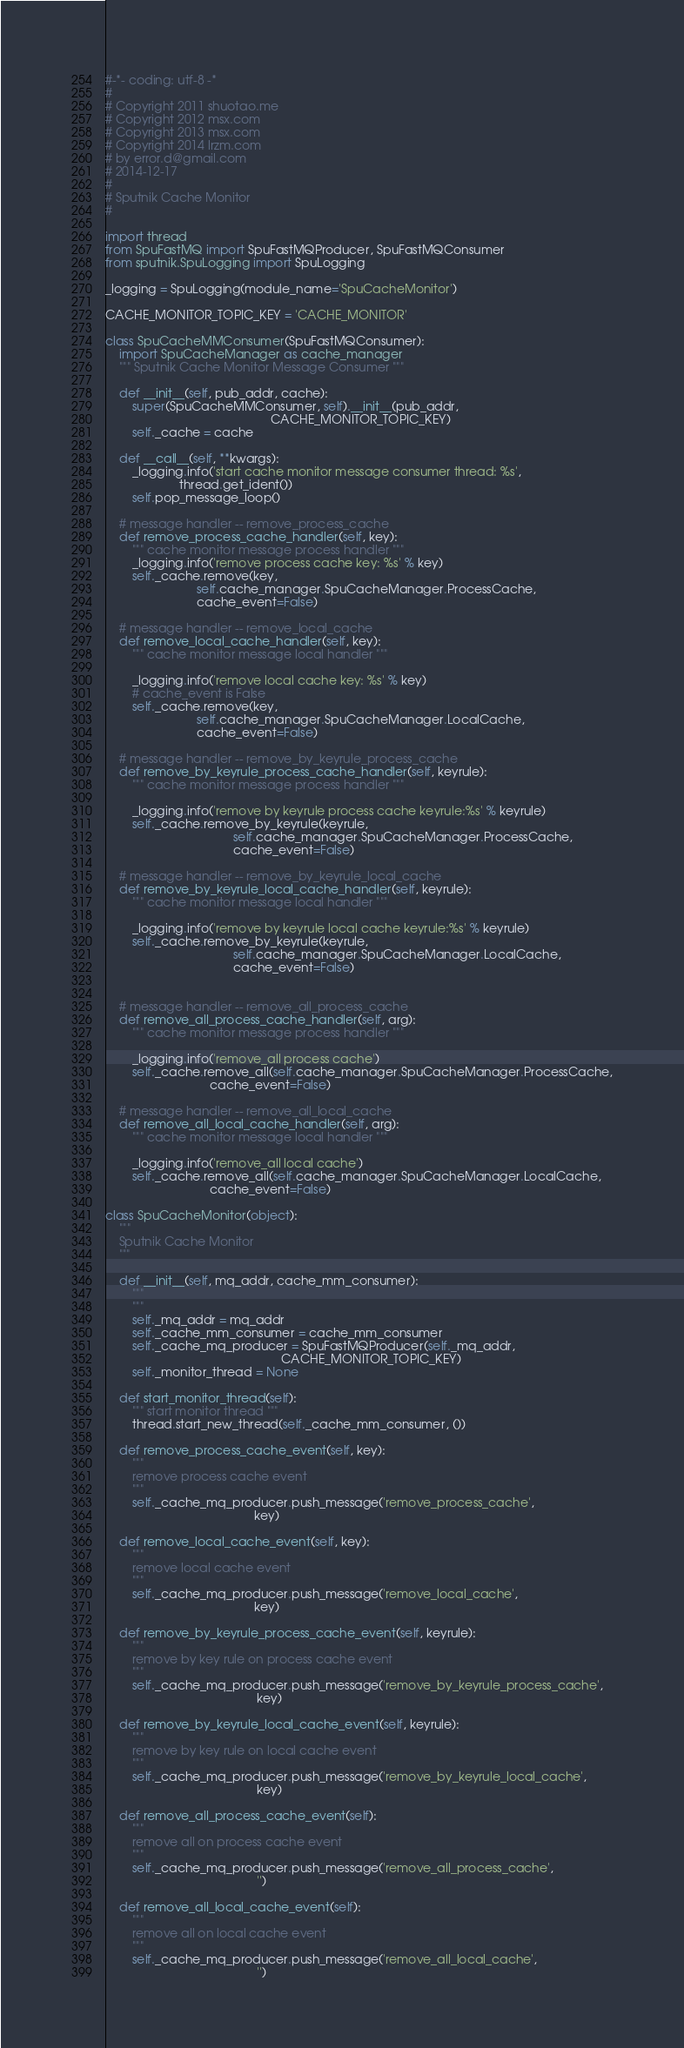<code> <loc_0><loc_0><loc_500><loc_500><_Python_>#-*- coding: utf-8 -*
#
# Copyright 2011 shuotao.me
# Copyright 2012 msx.com
# Copyright 2013 msx.com
# Copyright 2014 lrzm.com
# by error.d@gmail.com
# 2014-12-17
#
# Sputnik Cache Monitor
#

import thread
from SpuFastMQ import SpuFastMQProducer, SpuFastMQConsumer
from sputnik.SpuLogging import SpuLogging

_logging = SpuLogging(module_name='SpuCacheMonitor')

CACHE_MONITOR_TOPIC_KEY = 'CACHE_MONITOR'

class SpuCacheMMConsumer(SpuFastMQConsumer):
    import SpuCacheManager as cache_manager
    """ Sputnik Cache Monitor Message Consumer """

    def __init__(self, pub_addr, cache):
        super(SpuCacheMMConsumer, self).__init__(pub_addr,
                                                 CACHE_MONITOR_TOPIC_KEY)
        self._cache = cache

    def __call__(self, **kwargs):
        _logging.info('start cache monitor message consumer thread: %s',
                      thread.get_ident())
        self.pop_message_loop()

    # message handler -- remove_process_cache
    def remove_process_cache_handler(self, key):
        """ cache monitor message process handler """
        _logging.info('remove process cache key: %s' % key)
        self._cache.remove(key,
                           self.cache_manager.SpuCacheManager.ProcessCache,
                           cache_event=False)

    # message handler -- remove_local_cache
    def remove_local_cache_handler(self, key):
        """ cache monitor message local handler """

        _logging.info('remove local cache key: %s' % key)
        # cache_event is False
        self._cache.remove(key,
                           self.cache_manager.SpuCacheManager.LocalCache,
                           cache_event=False)

    # message handler -- remove_by_keyrule_process_cache
    def remove_by_keyrule_process_cache_handler(self, keyrule):
        """ cache monitor message process handler """ 

        _logging.info('remove by keyrule process cache keyrule:%s' % keyrule)
        self._cache.remove_by_keyrule(keyrule,
                                      self.cache_manager.SpuCacheManager.ProcessCache,
                                      cache_event=False)

    # message handler -- remove_by_keyrule_local_cache
    def remove_by_keyrule_local_cache_handler(self, keyrule):
        """ cache monitor message local handler """

        _logging.info('remove by keyrule local cache keyrule:%s' % keyrule)
        self._cache.remove_by_keyrule(keyrule,
                                      self.cache_manager.SpuCacheManager.LocalCache,
                                      cache_event=False)


    # message handler -- remove_all_process_cache
    def remove_all_process_cache_handler(self, arg):
        """ cache monitor message process handler """ 

        _logging.info('remove_all process cache')
        self._cache.remove_all(self.cache_manager.SpuCacheManager.ProcessCache,
                               cache_event=False)

    # message handler -- remove_all_local_cache
    def remove_all_local_cache_handler(self, arg):
        """ cache monitor message local handler """

        _logging.info('remove_all local cache')
        self._cache.remove_all(self.cache_manager.SpuCacheManager.LocalCache,
                               cache_event=False)

class SpuCacheMonitor(object):
    """
    Sputnik Cache Monitor
    """

    def __init__(self, mq_addr, cache_mm_consumer):
        """
        """
        self._mq_addr = mq_addr
        self._cache_mm_consumer = cache_mm_consumer
        self._cache_mq_producer = SpuFastMQProducer(self._mq_addr,
                                                    CACHE_MONITOR_TOPIC_KEY)
        self._monitor_thread = None

    def start_monitor_thread(self):
        """ start monitor thread """
        thread.start_new_thread(self._cache_mm_consumer, ())

    def remove_process_cache_event(self, key):
        """
        remove process cache event
        """
        self._cache_mq_producer.push_message('remove_process_cache',
                                            key) 

    def remove_local_cache_event(self, key):
        """
        remove local cache event
        """
        self._cache_mq_producer.push_message('remove_local_cache',
                                            key) 

    def remove_by_keyrule_process_cache_event(self, keyrule):
        """
        remove by key rule on process cache event
        """
        self._cache_mq_producer.push_message('remove_by_keyrule_process_cache',
                                             key) 

    def remove_by_keyrule_local_cache_event(self, keyrule):
        """
        remove by key rule on local cache event
        """
        self._cache_mq_producer.push_message('remove_by_keyrule_local_cache',
                                             key) 

    def remove_all_process_cache_event(self):
        """
        remove all on process cache event
        """
        self._cache_mq_producer.push_message('remove_all_process_cache',
                                             '')

    def remove_all_local_cache_event(self):
        """
        remove all on local cache event
        """
        self._cache_mq_producer.push_message('remove_all_local_cache',
                                             '') 
</code> 